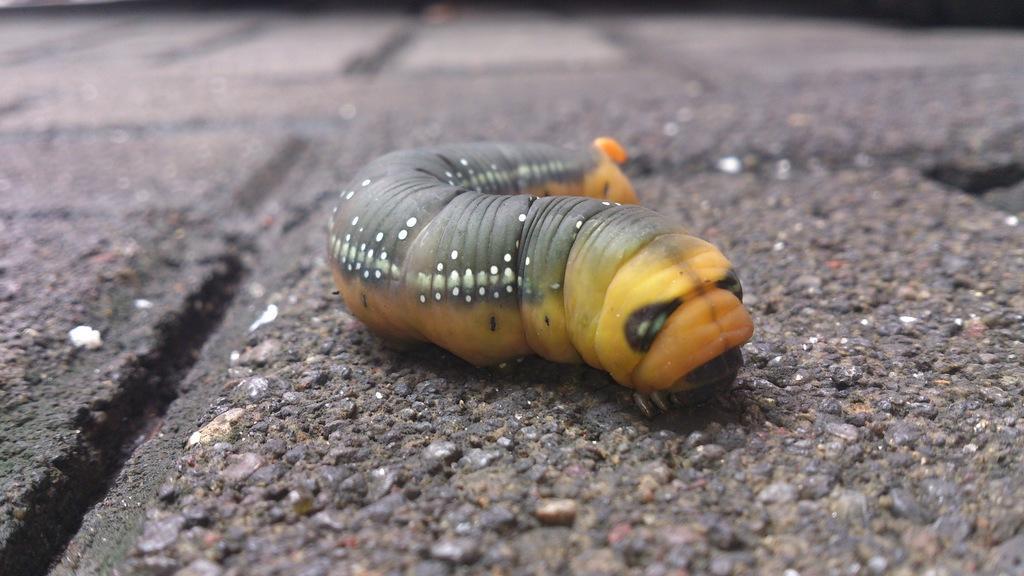Can you describe this image briefly? In this image I see an insect which is of black, white, orange and yellow in color and it is on the surface and I see that it is blurred in the background. 